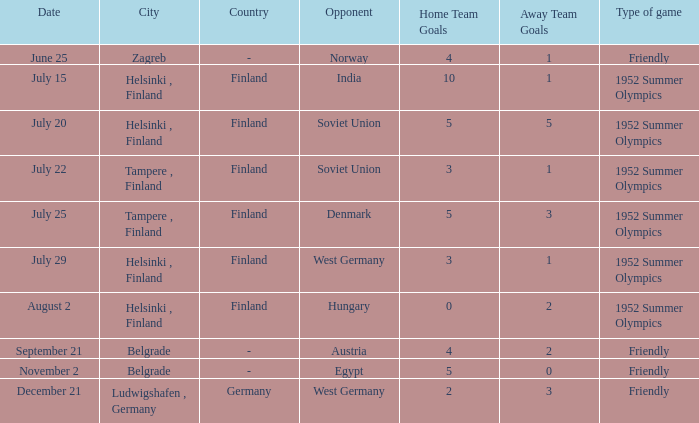What Type of game was played on Date of July 29? 1952 Summer Olympics. 